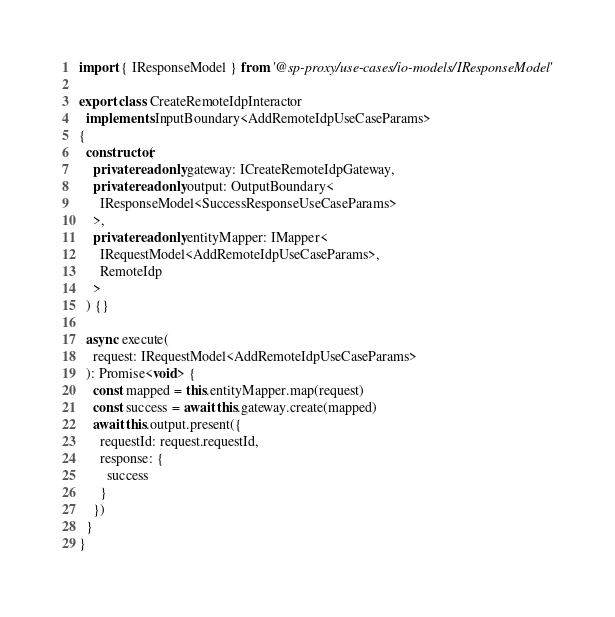Convert code to text. <code><loc_0><loc_0><loc_500><loc_500><_TypeScript_>import { IResponseModel } from '@sp-proxy/use-cases/io-models/IResponseModel'

export class CreateRemoteIdpInteractor
  implements InputBoundary<AddRemoteIdpUseCaseParams>
{
  constructor(
    private readonly gateway: ICreateRemoteIdpGateway,
    private readonly output: OutputBoundary<
      IResponseModel<SuccessResponseUseCaseParams>
    >,
    private readonly entityMapper: IMapper<
      IRequestModel<AddRemoteIdpUseCaseParams>,
      RemoteIdp
    >
  ) {}

  async execute(
    request: IRequestModel<AddRemoteIdpUseCaseParams>
  ): Promise<void> {
    const mapped = this.entityMapper.map(request)
    const success = await this.gateway.create(mapped)
    await this.output.present({
      requestId: request.requestId,
      response: {
        success
      }
    })
  }
}
</code> 